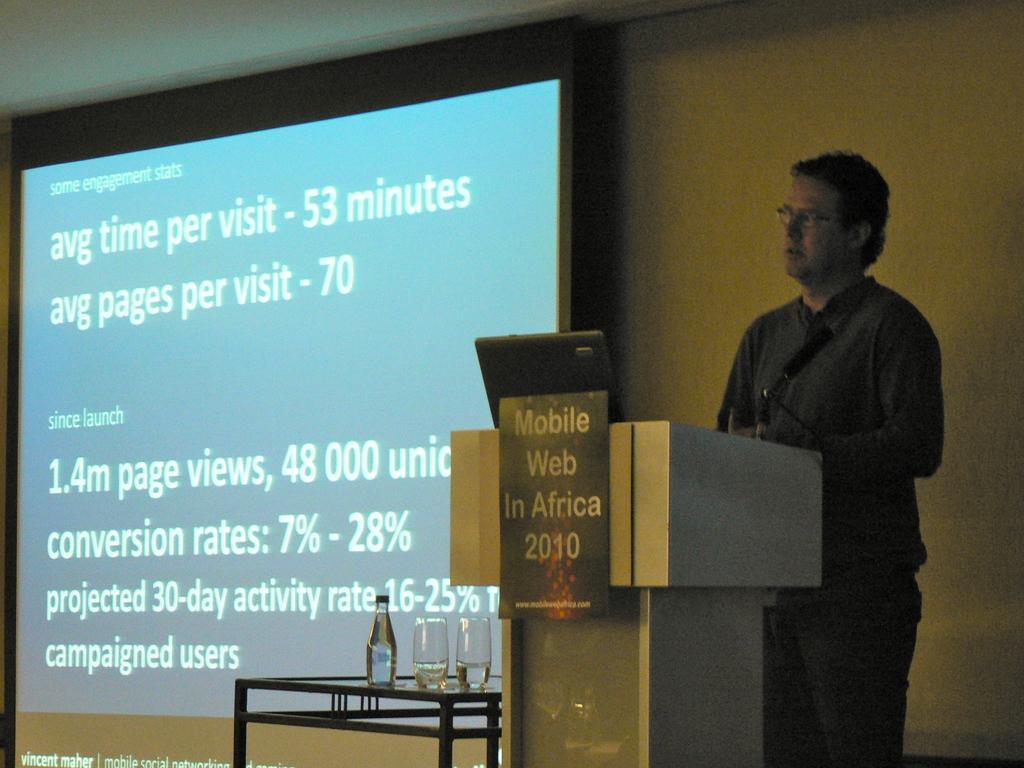In one or two sentences, can you explain what this image depicts? On the right corner picture, we see a man in black shirt is standing near the podium and on the podium, we see a laptop and we even see a poster with some text written on it. Beside that, we see a table on which water bottle and glass are placed. Behind that, we see a projector screen with some text displayed on it. Behind that, we see a yellow wall. 